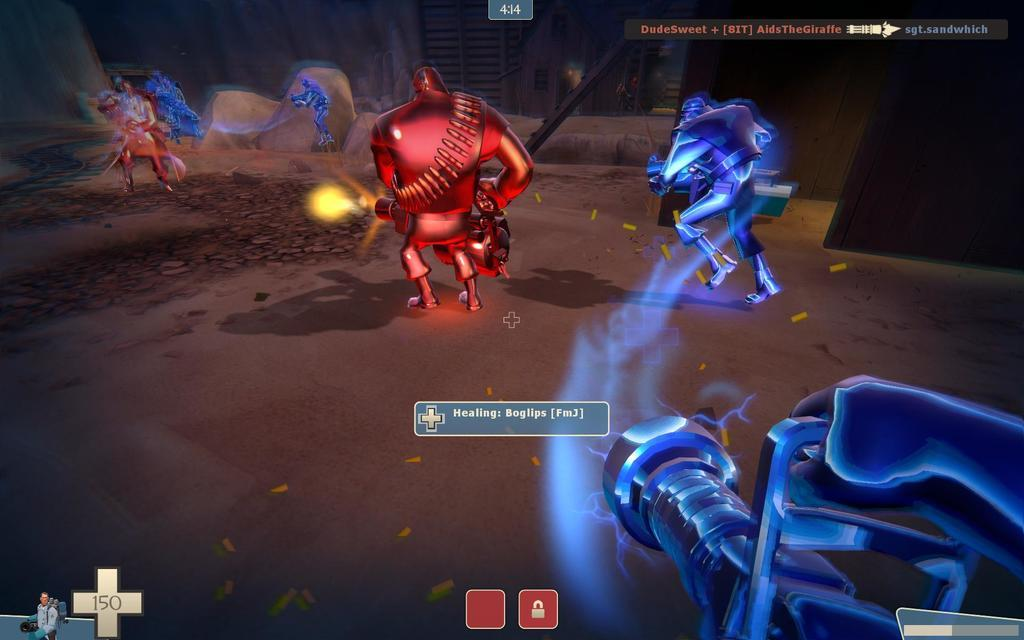What is the person in the image doing? The person is holding a camera and taking a picture. What can be seen in the background of the image? There is a building in the background of the image. Reasoning: We identified the main subject in the image, which is the person holding a camera and taking a picture. We then described the background of the image, which includes a building. Absurd Question/Answer: How many screws are visible on the sofa in the image? There is no sofa or screws present in the image. --- What are the people in the image wearing? The people are wearing different colored clothes. Reasoning: We identified the main subject in the image, which is the group of people standing together. We then described their clothing, noting that they are wearing different colors. Absurd Question/Answer: What type of lace is draped over the tree in the image? There is no lace present in the image. --- What is the car in the image doing? The car is parked on the side of the road. What can be seen in the background of the image? There are trees and a building in the background of the image. Reasoning: We identified the main subject in the image, which is the car parked on the side of the road. We then described the background of the image, which includes trees and a building. Absurd Question/Answer: How many cushions are on the sofa in the image? There is no sofa present in the image. --- What is the cat in the image sitting on? The cat is sitting on a chair. What is the chair made of? The chair is made of wood. Reasoning: We identified the main subject in the image, which is the cat sitting on a chair. We then described the chair, noting that it is made of wood. Absurd Question/Answer: What type of flowers are growing on the lace in the image? There is no lace or flowers present in the image. --- What is the dog in the image playing with? The dog is playing with a ball. What color is the ball? The ball is red in color. Reasoning: We identified the main subject in the image, which is the dog playing with a ball. We then described the ball, noting that it is red. Absurd Question/Answer: How many chairs are arranged around the sofa in the image? There is no sofa present in the image. --- What are the children in the image doing? The children are playing in a playground. What can be found in the playground? There are swings and slides in the playground. Reasoning: We identified the main subject in the image, which is the group of children playing in a playground. We then described the playground, noting that it has swings and slides. Absurd Question/Answer: What type of fabric is draped over the sofa in the image? There is no sofa present in the image. --- What is the person in the image doing? The person is riding a bicycle. What type of sofa is visible in the background of the image? There is no sofa present in the image. --- What can be seen at the beach in the image? There is sand and water at the beach. What are the people in the image doing? There are people swimming in the water. Reasoning: We identified the main subject in the image, which is the beach with sand and water. We then described the people in the image, noting that they are swimming in the water. Absurd Question/Answer: What type of lace is used to decorate the trees in the image? There is no lace present in the image. --- What are the people in the image doing? The people are sitting around a table. What are they doing together? They are having a meal together. Reasoning: We identified the main subject in the image, which is the group of people sitting around a table. We then described their activity, noting that they are having a meal together. Absurd Question/Answer: How many cushions are on the sofa in the image? There is no sofa present in the image. 